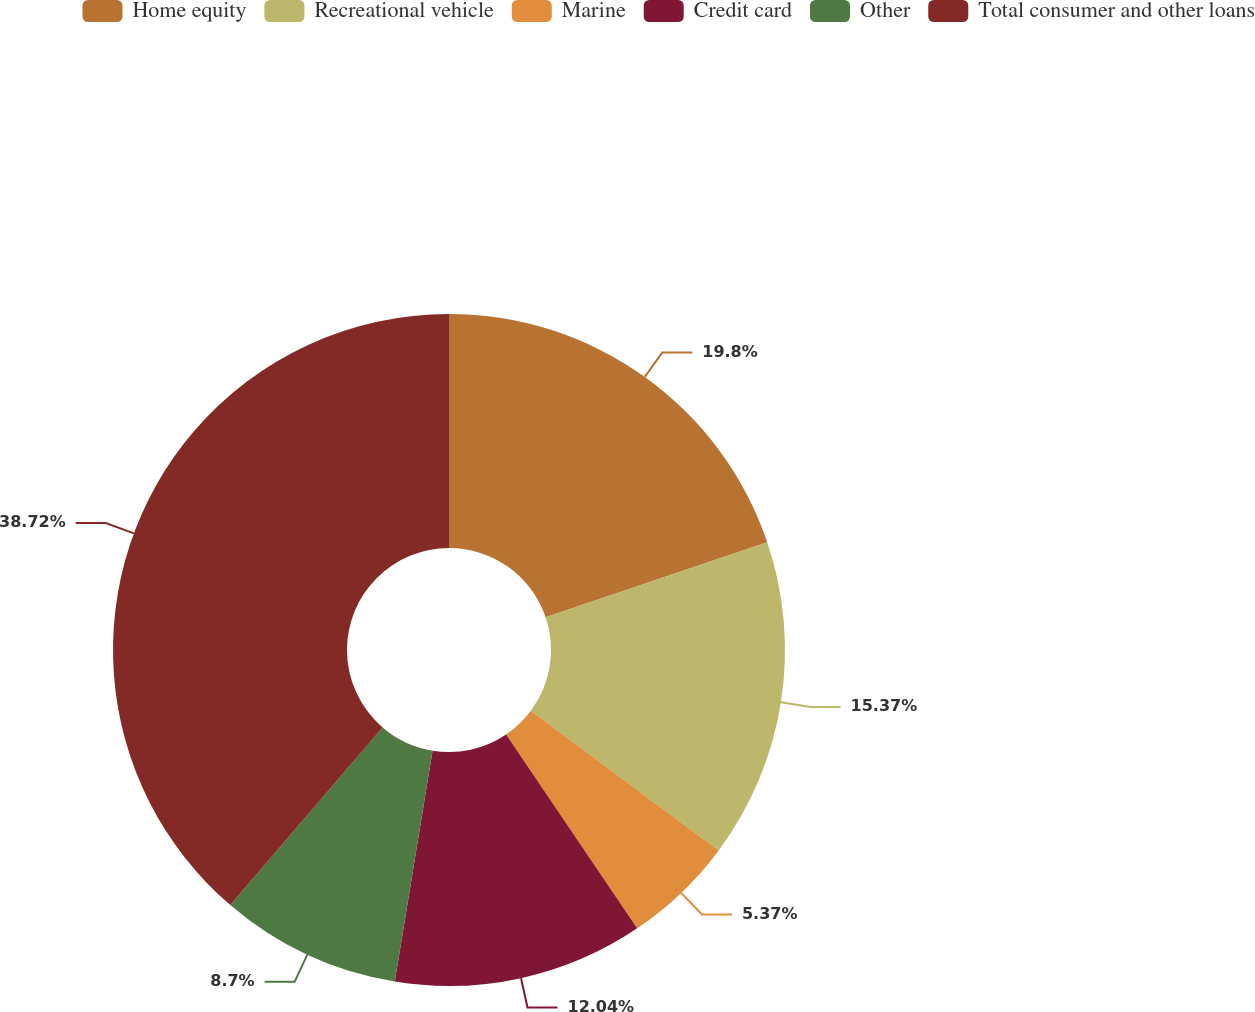Convert chart. <chart><loc_0><loc_0><loc_500><loc_500><pie_chart><fcel>Home equity<fcel>Recreational vehicle<fcel>Marine<fcel>Credit card<fcel>Other<fcel>Total consumer and other loans<nl><fcel>19.8%<fcel>15.37%<fcel>5.37%<fcel>12.04%<fcel>8.7%<fcel>38.72%<nl></chart> 